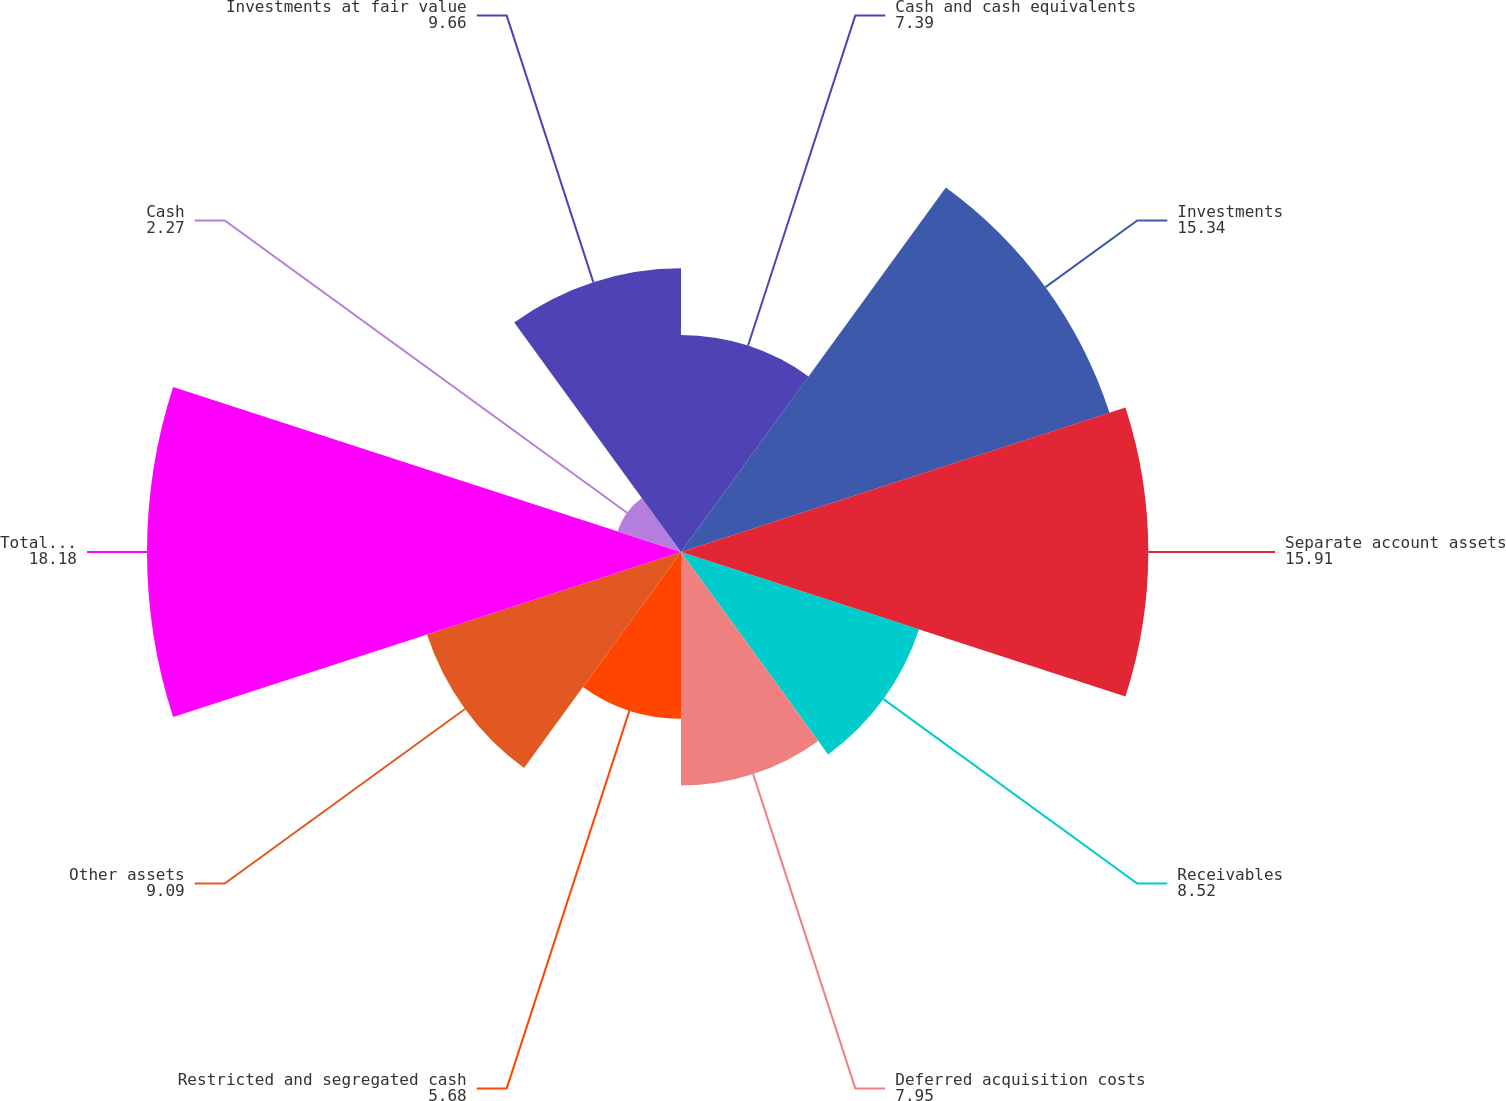Convert chart. <chart><loc_0><loc_0><loc_500><loc_500><pie_chart><fcel>Cash and cash equivalents<fcel>Investments<fcel>Separate account assets<fcel>Receivables<fcel>Deferred acquisition costs<fcel>Restricted and segregated cash<fcel>Other assets<fcel>Total assets before<fcel>Cash<fcel>Investments at fair value<nl><fcel>7.39%<fcel>15.34%<fcel>15.91%<fcel>8.52%<fcel>7.95%<fcel>5.68%<fcel>9.09%<fcel>18.18%<fcel>2.27%<fcel>9.66%<nl></chart> 